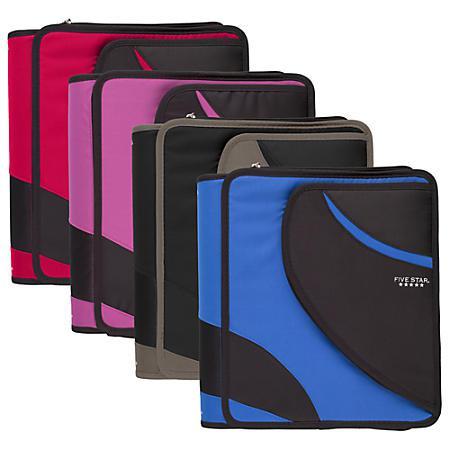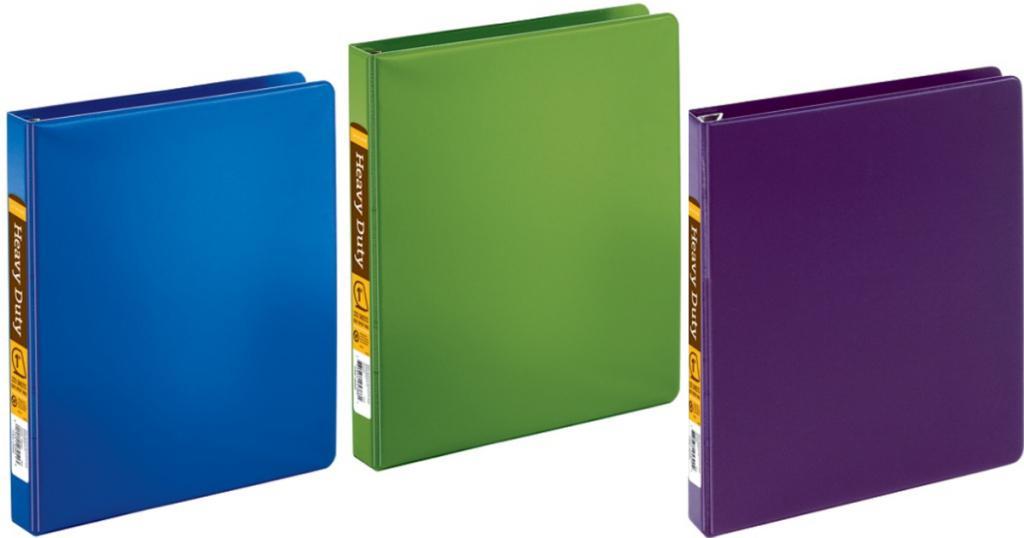The first image is the image on the left, the second image is the image on the right. Considering the images on both sides, is "The right image image depicts no more than three binders." valid? Answer yes or no. Yes. 